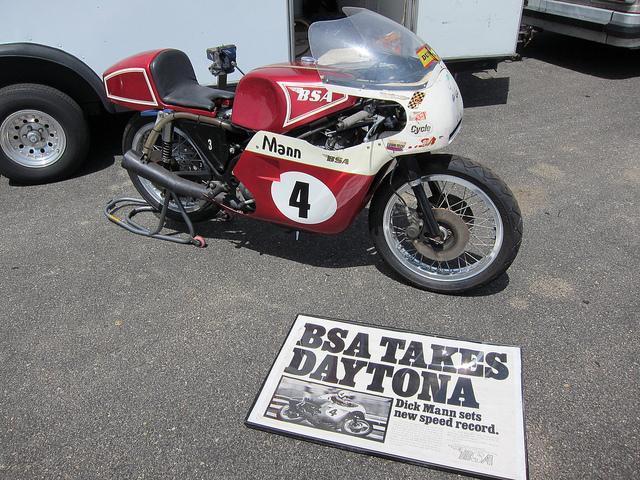What is the first name of the person who rode this bike?
Indicate the correct response and explain using: 'Answer: answer
Rationale: rationale.'
Options: Mary, mann, dick, manny. Answer: dick.
Rationale: The paper says dick mann. 